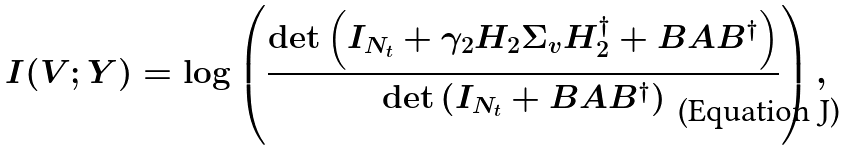<formula> <loc_0><loc_0><loc_500><loc_500>I ( V ; Y ) = \log \left ( \frac { \det \left ( I _ { N _ { t } } + \gamma _ { 2 } H _ { 2 } { \Sigma } _ { v } H _ { 2 } ^ { \dagger } + B A B ^ { \dagger } \right ) } { \det \left ( I _ { N _ { t } } + B A B ^ { \dagger } \right ) } \right ) ,</formula> 